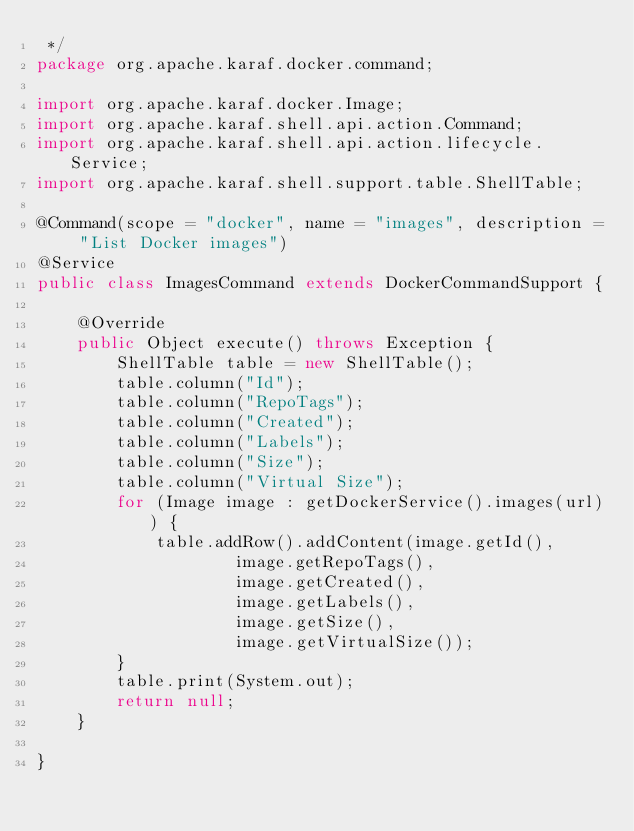<code> <loc_0><loc_0><loc_500><loc_500><_Java_> */
package org.apache.karaf.docker.command;

import org.apache.karaf.docker.Image;
import org.apache.karaf.shell.api.action.Command;
import org.apache.karaf.shell.api.action.lifecycle.Service;
import org.apache.karaf.shell.support.table.ShellTable;

@Command(scope = "docker", name = "images", description = "List Docker images")
@Service
public class ImagesCommand extends DockerCommandSupport {

    @Override
    public Object execute() throws Exception {
        ShellTable table = new ShellTable();
        table.column("Id");
        table.column("RepoTags");
        table.column("Created");
        table.column("Labels");
        table.column("Size");
        table.column("Virtual Size");
        for (Image image : getDockerService().images(url)) {
            table.addRow().addContent(image.getId(),
                    image.getRepoTags(),
                    image.getCreated(),
                    image.getLabels(),
                    image.getSize(),
                    image.getVirtualSize());
        }
        table.print(System.out);
        return null;
    }

}
</code> 